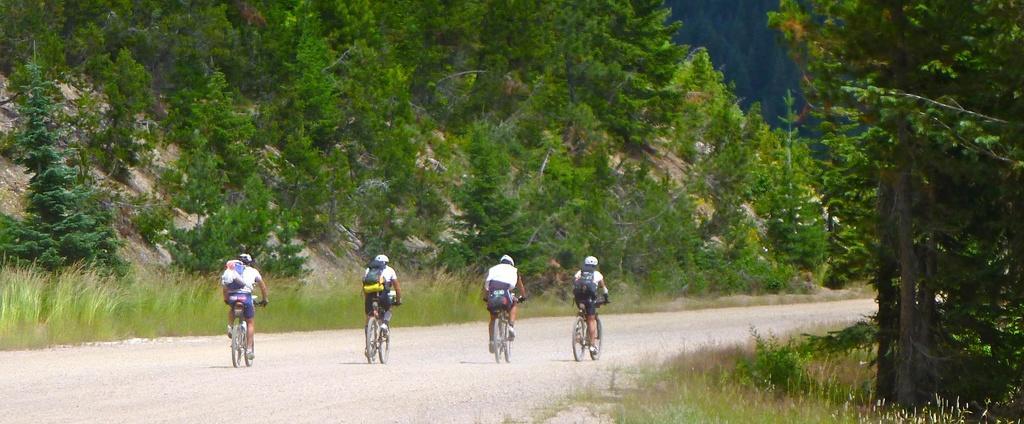Describe this image in one or two sentences. In this picture in the center there are persons riding bicycle. In the front there's grass on the ground. On the right side there are trees. In the background there are trees and there's grass on the ground. 